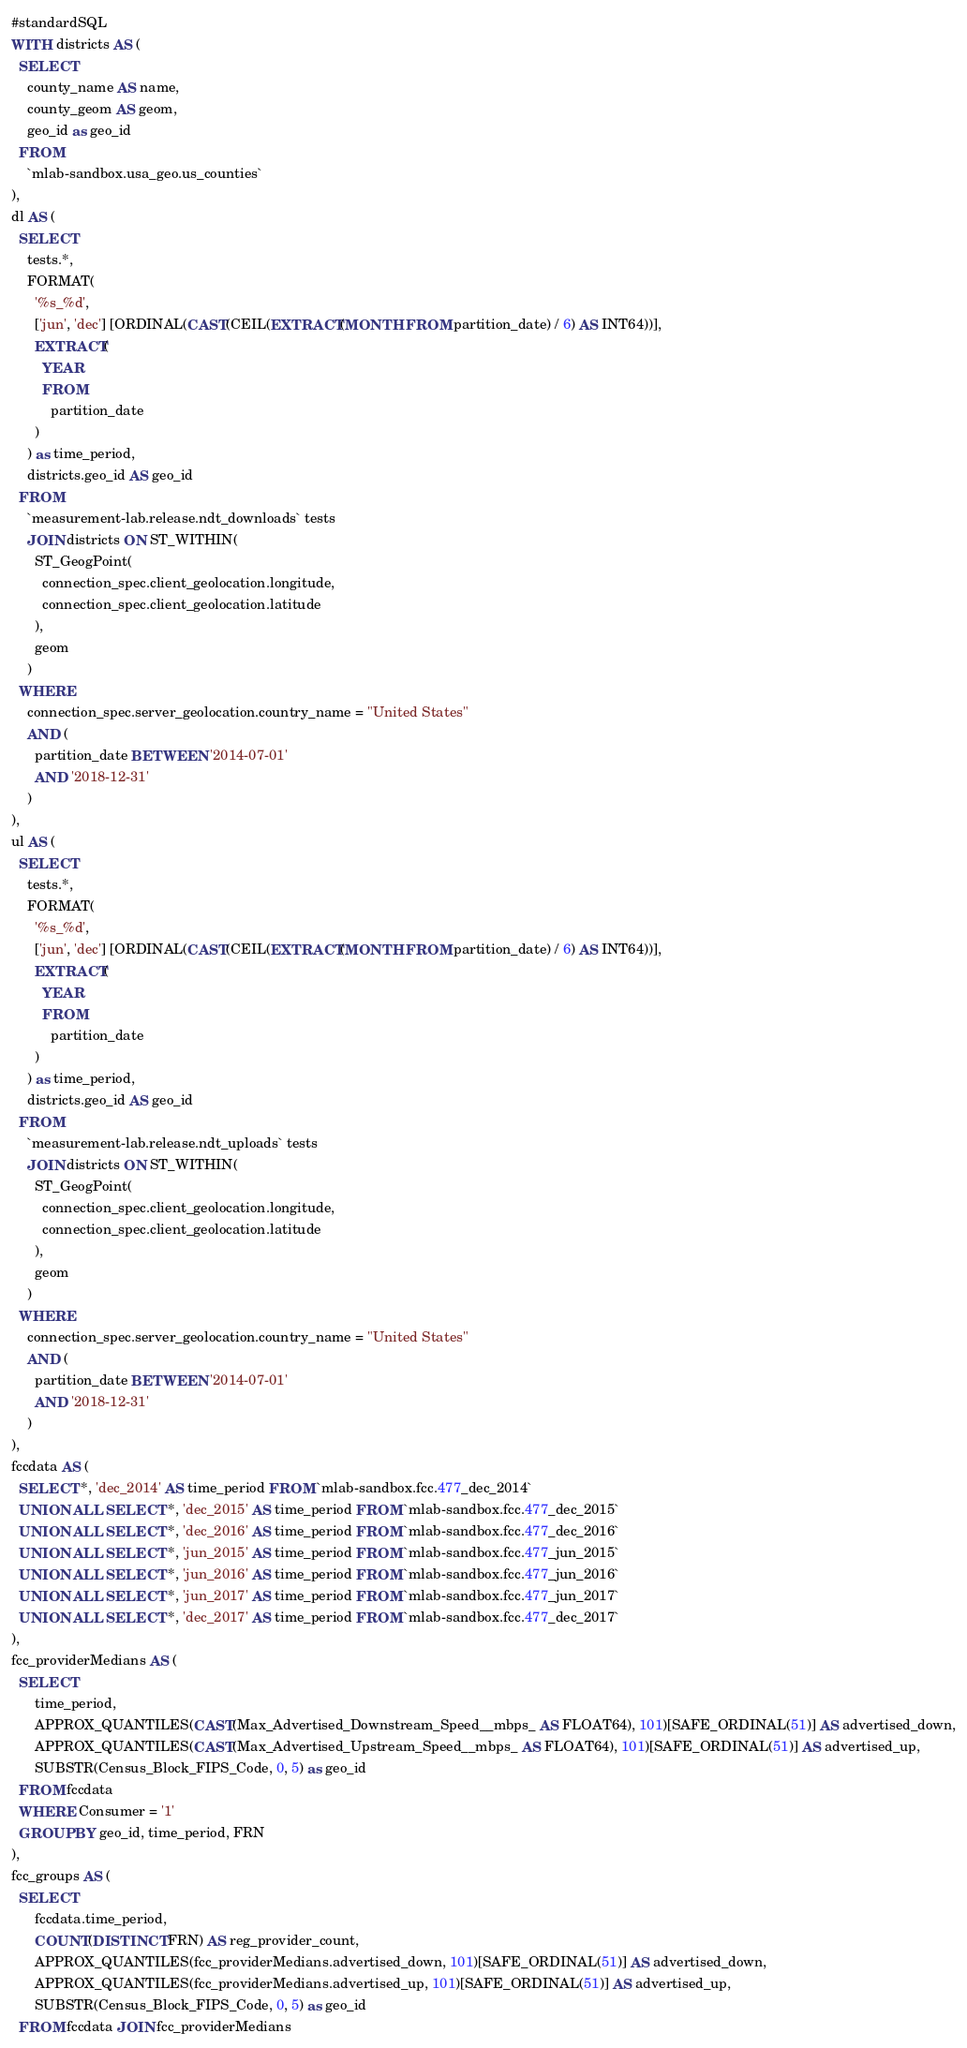<code> <loc_0><loc_0><loc_500><loc_500><_SQL_>#standardSQL
WITH districts AS (
  SELECT
    county_name AS name,
    county_geom AS geom,
    geo_id as geo_id
  FROM
    `mlab-sandbox.usa_geo.us_counties`
),
dl AS (
  SELECT
    tests.*,
    FORMAT(
      '%s_%d',
      ['jun', 'dec'] [ORDINAL(CAST(CEIL(EXTRACT(MONTH FROM partition_date) / 6) AS INT64))],
      EXTRACT(
        YEAR
        FROM
          partition_date
      )
    ) as time_period,
    districts.geo_id AS geo_id
  FROM
    `measurement-lab.release.ndt_downloads` tests
    JOIN districts ON ST_WITHIN(
      ST_GeogPoint(
        connection_spec.client_geolocation.longitude,
        connection_spec.client_geolocation.latitude
      ),
      geom
    )
  WHERE
    connection_spec.server_geolocation.country_name = "United States"
    AND (
      partition_date BETWEEN '2014-07-01'
      AND '2018-12-31'
    )
),
ul AS (
  SELECT
    tests.*,
    FORMAT(
      '%s_%d',
      ['jun', 'dec'] [ORDINAL(CAST(CEIL(EXTRACT(MONTH FROM partition_date) / 6) AS INT64))],
      EXTRACT(
        YEAR
        FROM
          partition_date
      )
    ) as time_period,
    districts.geo_id AS geo_id
  FROM
    `measurement-lab.release.ndt_uploads` tests
    JOIN districts ON ST_WITHIN(
      ST_GeogPoint(
        connection_spec.client_geolocation.longitude,
        connection_spec.client_geolocation.latitude
      ),
      geom
    )
  WHERE
    connection_spec.server_geolocation.country_name = "United States"
    AND (
      partition_date BETWEEN '2014-07-01'
      AND '2018-12-31'
    )
),
fccdata AS (
  SELECT *, 'dec_2014' AS time_period FROM `mlab-sandbox.fcc.477_dec_2014`
  UNION ALL SELECT *, 'dec_2015' AS time_period FROM `mlab-sandbox.fcc.477_dec_2015`
  UNION ALL SELECT *, 'dec_2016' AS time_period FROM `mlab-sandbox.fcc.477_dec_2016`
  UNION ALL SELECT *, 'jun_2015' AS time_period FROM `mlab-sandbox.fcc.477_jun_2015`
  UNION ALL SELECT *, 'jun_2016' AS time_period FROM `mlab-sandbox.fcc.477_jun_2016`
  UNION ALL SELECT *, 'jun_2017' AS time_period FROM `mlab-sandbox.fcc.477_jun_2017`
  UNION ALL SELECT *, 'dec_2017' AS time_period FROM `mlab-sandbox.fcc.477_dec_2017`
),
fcc_providerMedians AS (
  SELECT
      time_period,
      APPROX_QUANTILES(CAST(Max_Advertised_Downstream_Speed__mbps_ AS FLOAT64), 101)[SAFE_ORDINAL(51)] AS advertised_down,
      APPROX_QUANTILES(CAST(Max_Advertised_Upstream_Speed__mbps_ AS FLOAT64), 101)[SAFE_ORDINAL(51)] AS advertised_up,
      SUBSTR(Census_Block_FIPS_Code, 0, 5) as geo_id
  FROM fccdata
  WHERE Consumer = '1'
  GROUP BY geo_id, time_period, FRN
),
fcc_groups AS (
  SELECT
      fccdata.time_period,
      COUNT(DISTINCT FRN) AS reg_provider_count, 
      APPROX_QUANTILES(fcc_providerMedians.advertised_down, 101)[SAFE_ORDINAL(51)] AS advertised_down,
      APPROX_QUANTILES(fcc_providerMedians.advertised_up, 101)[SAFE_ORDINAL(51)] AS advertised_up,
      SUBSTR(Census_Block_FIPS_Code, 0, 5) as geo_id
  FROM fccdata JOIN fcc_providerMedians </code> 